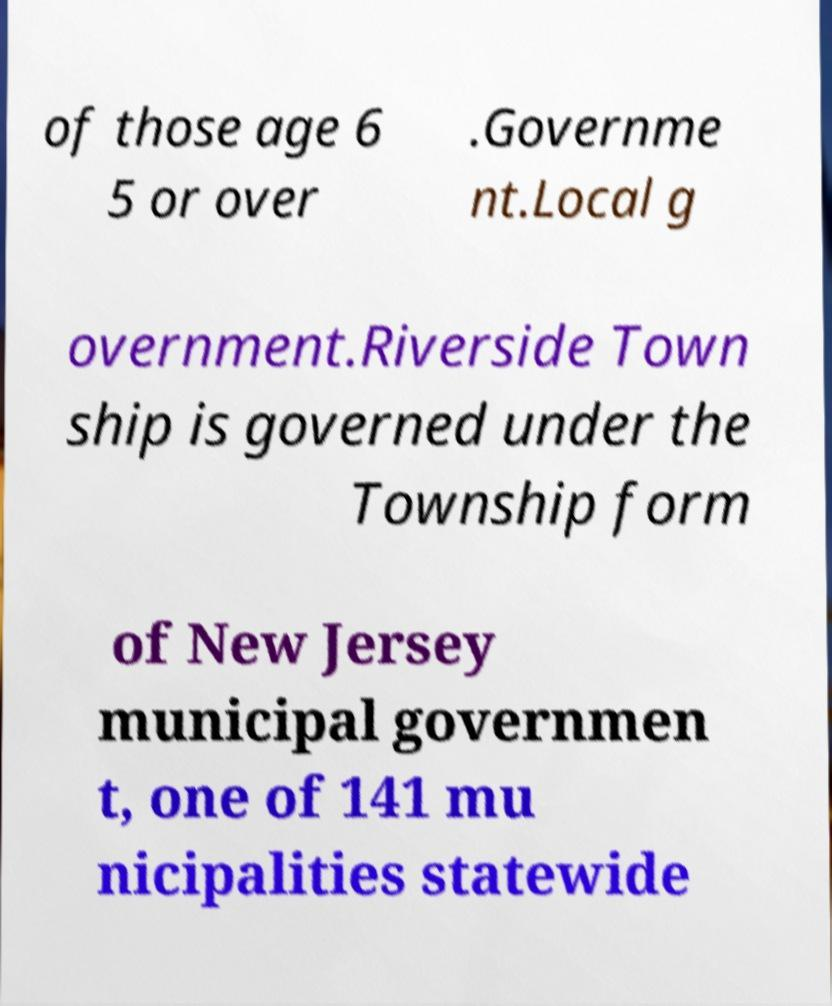I need the written content from this picture converted into text. Can you do that? of those age 6 5 or over .Governme nt.Local g overnment.Riverside Town ship is governed under the Township form of New Jersey municipal governmen t, one of 141 mu nicipalities statewide 